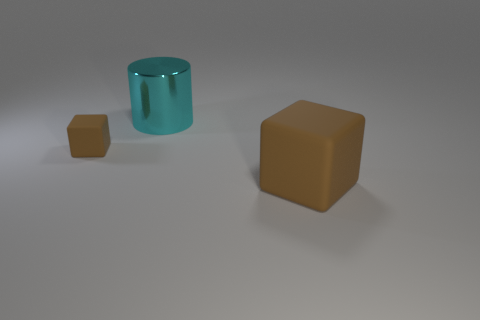Can you describe the lighting and atmosphere in the scene depicted in the image? The scene has a soft and diffuse lighting, casting gentle shadows on the objects, which suggests an evenly lit environment. The overall atmosphere appears calm and minimalistic, possibly an indoor setting with a neutral background. This type of lighting is often used to highlight the form and color of objects without creating harsh shadows or highlights. 